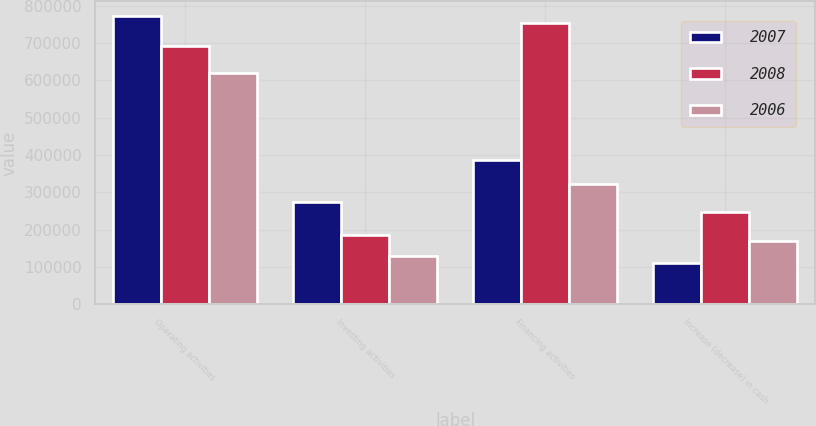Convert chart to OTSL. <chart><loc_0><loc_0><loc_500><loc_500><stacked_bar_chart><ecel><fcel>Operating activities<fcel>Investing activities<fcel>Financing activities<fcel>Increase (decrease) in cash<nl><fcel>2007<fcel>773258<fcel>274940<fcel>388172<fcel>109954<nl><fcel>2008<fcel>692679<fcel>186180<fcel>754640<fcel>248141<nl><fcel>2006<fcel>620738<fcel>129112<fcel>323063<fcel>168563<nl></chart> 